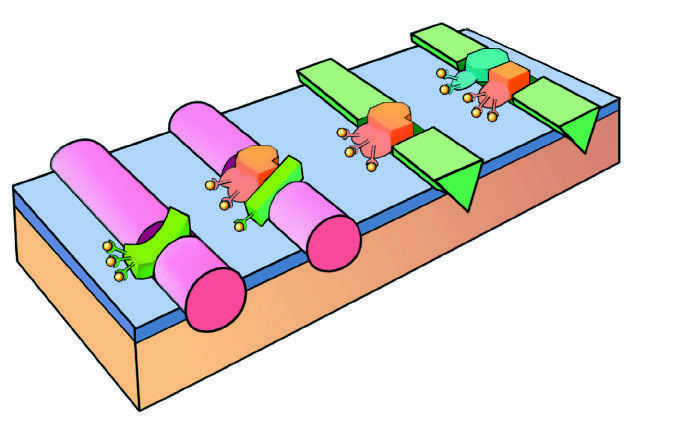what consists of a protease, a substrate, and a reaction accelerator assembled on a platelet phospholipid surface?
Answer the question using a single word or phrase. The initial reaction complex 